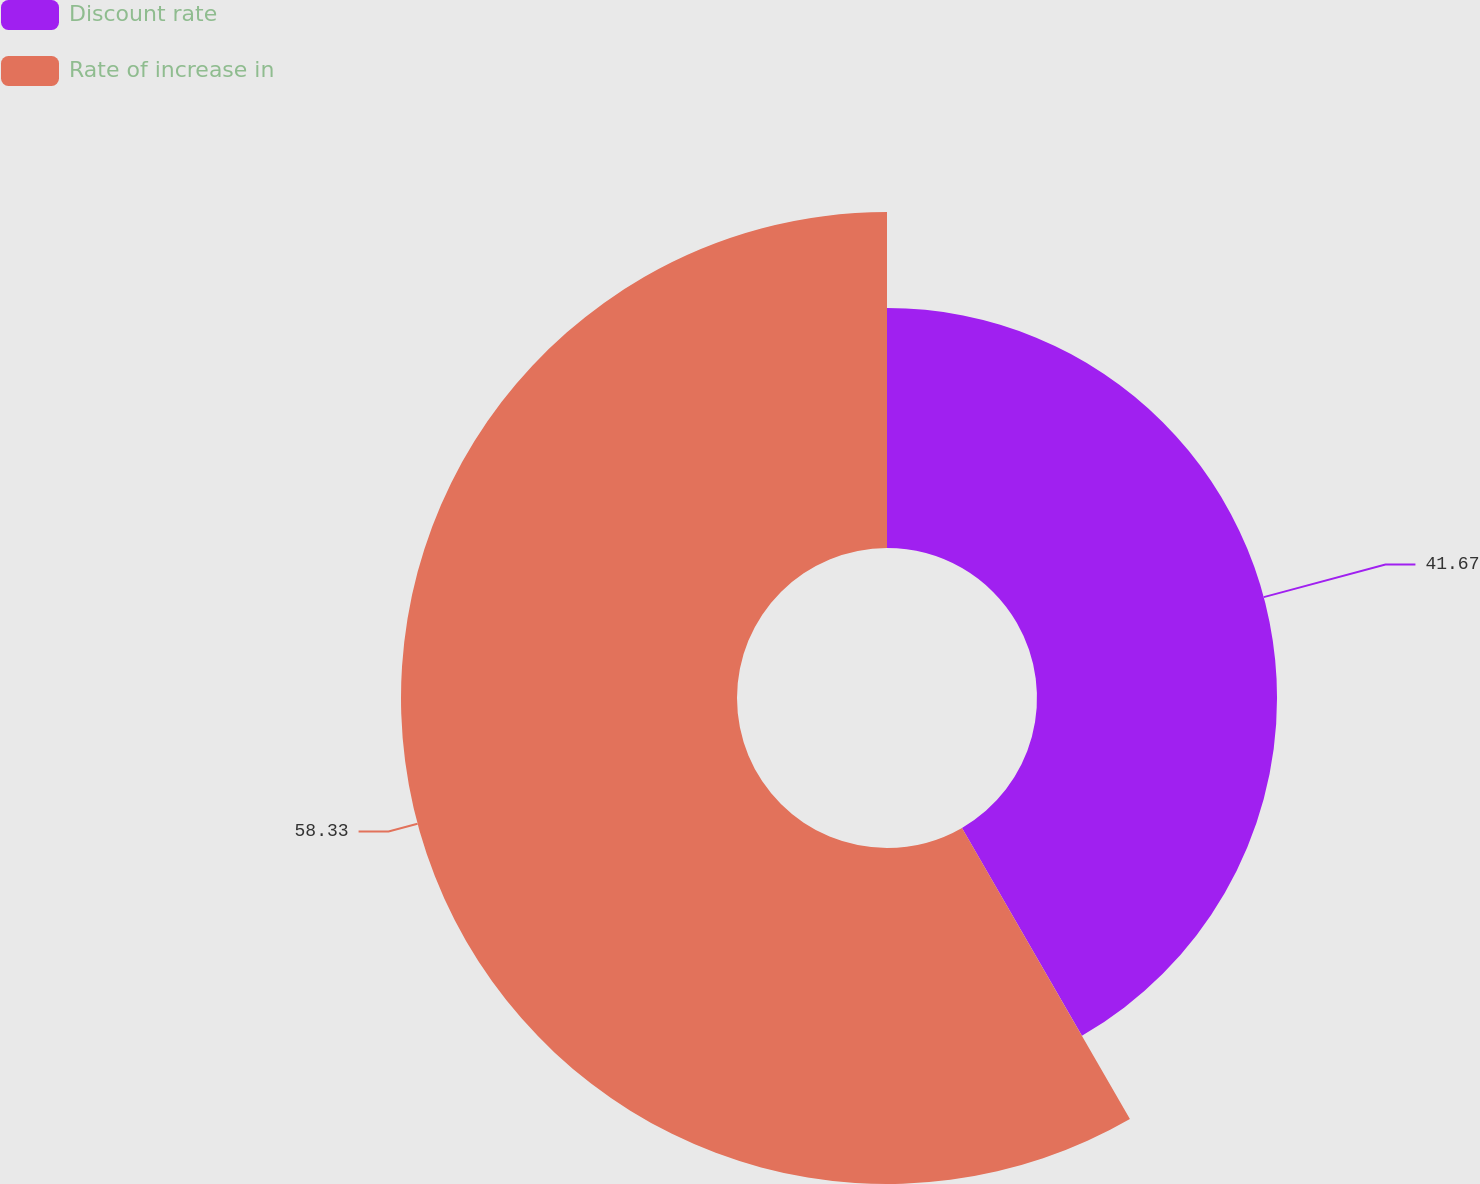<chart> <loc_0><loc_0><loc_500><loc_500><pie_chart><fcel>Discount rate<fcel>Rate of increase in<nl><fcel>41.67%<fcel>58.33%<nl></chart> 